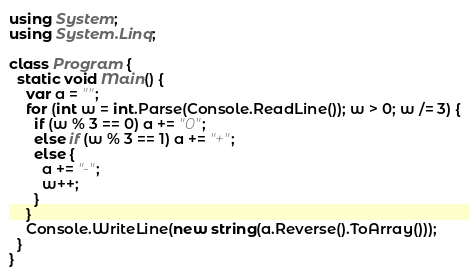<code> <loc_0><loc_0><loc_500><loc_500><_C#_>using System;
using System.Linq;

class Program {
  static void Main() {
    var a = "";
    for (int w = int.Parse(Console.ReadLine()); w > 0; w /= 3) {
      if (w % 3 == 0) a += "0";
      else if (w % 3 == 1) a += "+";
      else {
        a += "-";
        w++;
      }
    }
    Console.WriteLine(new string(a.Reverse().ToArray()));
  }
}
</code> 